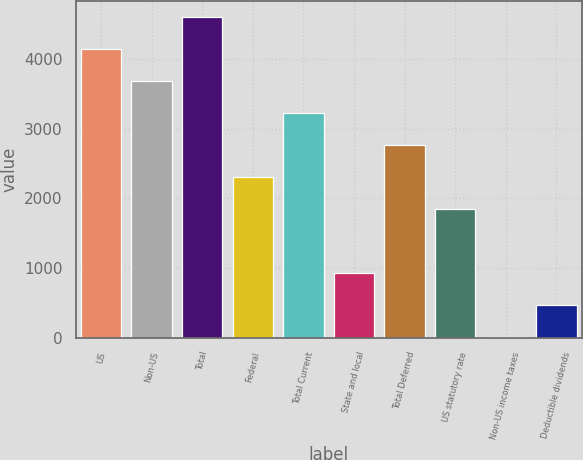Convert chart. <chart><loc_0><loc_0><loc_500><loc_500><bar_chart><fcel>US<fcel>Non-US<fcel>Total<fcel>Federal<fcel>Total Current<fcel>State and local<fcel>Total Deferred<fcel>US statutory rate<fcel>Non-US income taxes<fcel>Deductible dividends<nl><fcel>4140.2<fcel>3680.4<fcel>4600<fcel>2301<fcel>3220.6<fcel>921.6<fcel>2760.8<fcel>1841.2<fcel>2<fcel>461.8<nl></chart> 